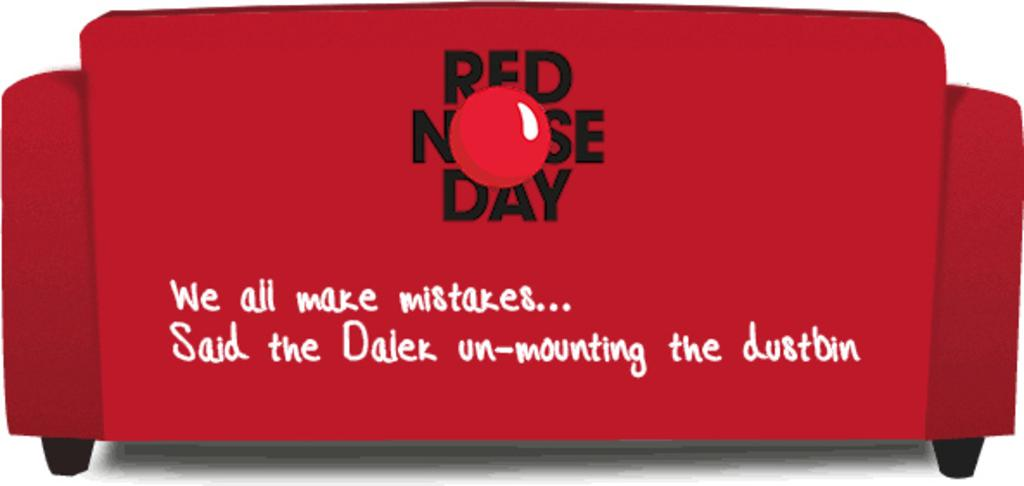What type of furniture is present in the image? There is a couch in the image. What color is the couch? The couch is red in color. Is there any text or writing on the couch? Yes, there is text written on the couch. What language is the voice speaking in the image? There is no voice or speaking in the image; it only features a red couch with text on it. 